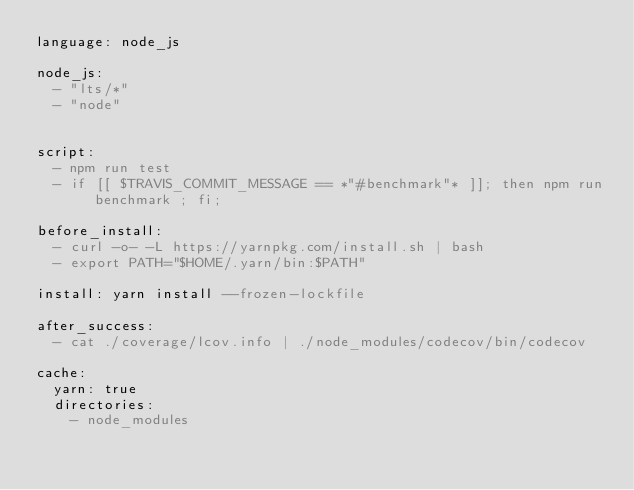Convert code to text. <code><loc_0><loc_0><loc_500><loc_500><_YAML_>language: node_js

node_js:
  - "lts/*"
  - "node"


script:
  - npm run test
  - if [[ $TRAVIS_COMMIT_MESSAGE == *"#benchmark"* ]]; then npm run benchmark ; fi;

before_install:
  - curl -o- -L https://yarnpkg.com/install.sh | bash
  - export PATH="$HOME/.yarn/bin:$PATH"

install: yarn install --frozen-lockfile

after_success:
  - cat ./coverage/lcov.info | ./node_modules/codecov/bin/codecov

cache:
  yarn: true
  directories:
    - node_modules
</code> 